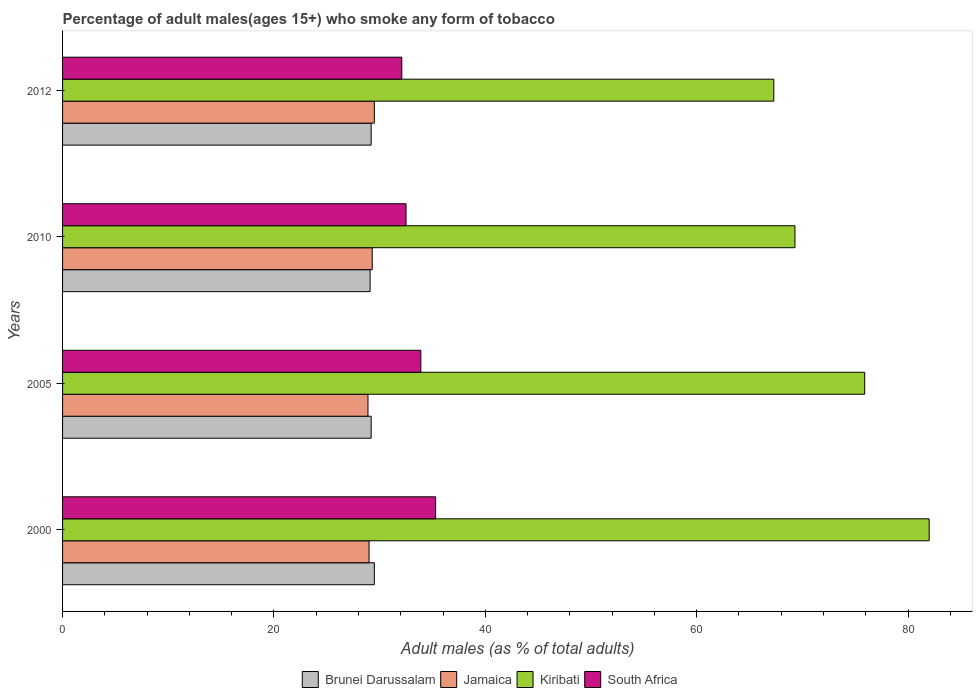How many bars are there on the 3rd tick from the top?
Your answer should be very brief. 4. How many bars are there on the 3rd tick from the bottom?
Make the answer very short. 4. What is the label of the 2nd group of bars from the top?
Keep it short and to the point. 2010. What is the percentage of adult males who smoke in South Africa in 2000?
Offer a terse response. 35.3. Across all years, what is the maximum percentage of adult males who smoke in Jamaica?
Your answer should be compact. 29.5. Across all years, what is the minimum percentage of adult males who smoke in Kiribati?
Provide a short and direct response. 67.3. What is the total percentage of adult males who smoke in Jamaica in the graph?
Ensure brevity in your answer.  116.7. What is the difference between the percentage of adult males who smoke in South Africa in 2005 and that in 2010?
Offer a terse response. 1.4. What is the difference between the percentage of adult males who smoke in Brunei Darussalam in 2010 and the percentage of adult males who smoke in Jamaica in 2012?
Offer a terse response. -0.4. What is the average percentage of adult males who smoke in Brunei Darussalam per year?
Provide a succinct answer. 29.25. In the year 2005, what is the difference between the percentage of adult males who smoke in Jamaica and percentage of adult males who smoke in Brunei Darussalam?
Keep it short and to the point. -0.3. In how many years, is the percentage of adult males who smoke in Kiribati greater than 36 %?
Your answer should be compact. 4. What is the ratio of the percentage of adult males who smoke in Kiribati in 2005 to that in 2010?
Your response must be concise. 1.1. Is the percentage of adult males who smoke in Kiribati in 2005 less than that in 2010?
Offer a terse response. No. What is the difference between the highest and the second highest percentage of adult males who smoke in Kiribati?
Your response must be concise. 6.1. What is the difference between the highest and the lowest percentage of adult males who smoke in Brunei Darussalam?
Give a very brief answer. 0.4. Is the sum of the percentage of adult males who smoke in South Africa in 2005 and 2012 greater than the maximum percentage of adult males who smoke in Kiribati across all years?
Your answer should be very brief. No. Is it the case that in every year, the sum of the percentage of adult males who smoke in South Africa and percentage of adult males who smoke in Kiribati is greater than the sum of percentage of adult males who smoke in Jamaica and percentage of adult males who smoke in Brunei Darussalam?
Provide a succinct answer. Yes. What does the 2nd bar from the top in 2000 represents?
Ensure brevity in your answer.  Kiribati. What does the 2nd bar from the bottom in 2005 represents?
Offer a terse response. Jamaica. How many bars are there?
Keep it short and to the point. 16. Are all the bars in the graph horizontal?
Offer a terse response. Yes. How many years are there in the graph?
Your answer should be very brief. 4. Are the values on the major ticks of X-axis written in scientific E-notation?
Offer a terse response. No. How many legend labels are there?
Your answer should be very brief. 4. How are the legend labels stacked?
Ensure brevity in your answer.  Horizontal. What is the title of the graph?
Offer a terse response. Percentage of adult males(ages 15+) who smoke any form of tobacco. What is the label or title of the X-axis?
Your response must be concise. Adult males (as % of total adults). What is the label or title of the Y-axis?
Ensure brevity in your answer.  Years. What is the Adult males (as % of total adults) of Brunei Darussalam in 2000?
Your answer should be very brief. 29.5. What is the Adult males (as % of total adults) of Jamaica in 2000?
Your answer should be very brief. 29. What is the Adult males (as % of total adults) in Kiribati in 2000?
Give a very brief answer. 82. What is the Adult males (as % of total adults) of South Africa in 2000?
Offer a very short reply. 35.3. What is the Adult males (as % of total adults) in Brunei Darussalam in 2005?
Provide a succinct answer. 29.2. What is the Adult males (as % of total adults) in Jamaica in 2005?
Your answer should be compact. 28.9. What is the Adult males (as % of total adults) of Kiribati in 2005?
Your answer should be very brief. 75.9. What is the Adult males (as % of total adults) of South Africa in 2005?
Provide a succinct answer. 33.9. What is the Adult males (as % of total adults) of Brunei Darussalam in 2010?
Ensure brevity in your answer.  29.1. What is the Adult males (as % of total adults) of Jamaica in 2010?
Offer a very short reply. 29.3. What is the Adult males (as % of total adults) of Kiribati in 2010?
Give a very brief answer. 69.3. What is the Adult males (as % of total adults) of South Africa in 2010?
Ensure brevity in your answer.  32.5. What is the Adult males (as % of total adults) in Brunei Darussalam in 2012?
Provide a short and direct response. 29.2. What is the Adult males (as % of total adults) of Jamaica in 2012?
Make the answer very short. 29.5. What is the Adult males (as % of total adults) in Kiribati in 2012?
Your answer should be compact. 67.3. What is the Adult males (as % of total adults) in South Africa in 2012?
Your answer should be compact. 32.1. Across all years, what is the maximum Adult males (as % of total adults) of Brunei Darussalam?
Give a very brief answer. 29.5. Across all years, what is the maximum Adult males (as % of total adults) in Jamaica?
Your answer should be very brief. 29.5. Across all years, what is the maximum Adult males (as % of total adults) in Kiribati?
Make the answer very short. 82. Across all years, what is the maximum Adult males (as % of total adults) of South Africa?
Your response must be concise. 35.3. Across all years, what is the minimum Adult males (as % of total adults) in Brunei Darussalam?
Give a very brief answer. 29.1. Across all years, what is the minimum Adult males (as % of total adults) in Jamaica?
Your response must be concise. 28.9. Across all years, what is the minimum Adult males (as % of total adults) in Kiribati?
Keep it short and to the point. 67.3. Across all years, what is the minimum Adult males (as % of total adults) in South Africa?
Provide a succinct answer. 32.1. What is the total Adult males (as % of total adults) in Brunei Darussalam in the graph?
Offer a very short reply. 117. What is the total Adult males (as % of total adults) of Jamaica in the graph?
Your answer should be compact. 116.7. What is the total Adult males (as % of total adults) in Kiribati in the graph?
Your answer should be very brief. 294.5. What is the total Adult males (as % of total adults) in South Africa in the graph?
Ensure brevity in your answer.  133.8. What is the difference between the Adult males (as % of total adults) in Brunei Darussalam in 2000 and that in 2005?
Give a very brief answer. 0.3. What is the difference between the Adult males (as % of total adults) of Jamaica in 2000 and that in 2005?
Your response must be concise. 0.1. What is the difference between the Adult males (as % of total adults) in Kiribati in 2000 and that in 2005?
Give a very brief answer. 6.1. What is the difference between the Adult males (as % of total adults) in Brunei Darussalam in 2000 and that in 2010?
Your answer should be compact. 0.4. What is the difference between the Adult males (as % of total adults) of Jamaica in 2000 and that in 2010?
Make the answer very short. -0.3. What is the difference between the Adult males (as % of total adults) in South Africa in 2000 and that in 2010?
Your answer should be compact. 2.8. What is the difference between the Adult males (as % of total adults) of South Africa in 2000 and that in 2012?
Keep it short and to the point. 3.2. What is the difference between the Adult males (as % of total adults) of Kiribati in 2005 and that in 2010?
Make the answer very short. 6.6. What is the difference between the Adult males (as % of total adults) in South Africa in 2005 and that in 2010?
Your answer should be very brief. 1.4. What is the difference between the Adult males (as % of total adults) in Brunei Darussalam in 2005 and that in 2012?
Provide a short and direct response. 0. What is the difference between the Adult males (as % of total adults) in Jamaica in 2005 and that in 2012?
Offer a very short reply. -0.6. What is the difference between the Adult males (as % of total adults) of South Africa in 2005 and that in 2012?
Give a very brief answer. 1.8. What is the difference between the Adult males (as % of total adults) of Brunei Darussalam in 2010 and that in 2012?
Your answer should be very brief. -0.1. What is the difference between the Adult males (as % of total adults) in Jamaica in 2010 and that in 2012?
Give a very brief answer. -0.2. What is the difference between the Adult males (as % of total adults) in Kiribati in 2010 and that in 2012?
Make the answer very short. 2. What is the difference between the Adult males (as % of total adults) of Brunei Darussalam in 2000 and the Adult males (as % of total adults) of Kiribati in 2005?
Your answer should be compact. -46.4. What is the difference between the Adult males (as % of total adults) in Jamaica in 2000 and the Adult males (as % of total adults) in Kiribati in 2005?
Keep it short and to the point. -46.9. What is the difference between the Adult males (as % of total adults) of Jamaica in 2000 and the Adult males (as % of total adults) of South Africa in 2005?
Give a very brief answer. -4.9. What is the difference between the Adult males (as % of total adults) in Kiribati in 2000 and the Adult males (as % of total adults) in South Africa in 2005?
Your response must be concise. 48.1. What is the difference between the Adult males (as % of total adults) of Brunei Darussalam in 2000 and the Adult males (as % of total adults) of Kiribati in 2010?
Offer a terse response. -39.8. What is the difference between the Adult males (as % of total adults) in Jamaica in 2000 and the Adult males (as % of total adults) in Kiribati in 2010?
Your response must be concise. -40.3. What is the difference between the Adult males (as % of total adults) of Jamaica in 2000 and the Adult males (as % of total adults) of South Africa in 2010?
Offer a very short reply. -3.5. What is the difference between the Adult males (as % of total adults) in Kiribati in 2000 and the Adult males (as % of total adults) in South Africa in 2010?
Provide a short and direct response. 49.5. What is the difference between the Adult males (as % of total adults) in Brunei Darussalam in 2000 and the Adult males (as % of total adults) in Kiribati in 2012?
Provide a succinct answer. -37.8. What is the difference between the Adult males (as % of total adults) of Jamaica in 2000 and the Adult males (as % of total adults) of Kiribati in 2012?
Offer a terse response. -38.3. What is the difference between the Adult males (as % of total adults) of Jamaica in 2000 and the Adult males (as % of total adults) of South Africa in 2012?
Offer a very short reply. -3.1. What is the difference between the Adult males (as % of total adults) of Kiribati in 2000 and the Adult males (as % of total adults) of South Africa in 2012?
Make the answer very short. 49.9. What is the difference between the Adult males (as % of total adults) in Brunei Darussalam in 2005 and the Adult males (as % of total adults) in Kiribati in 2010?
Make the answer very short. -40.1. What is the difference between the Adult males (as % of total adults) in Brunei Darussalam in 2005 and the Adult males (as % of total adults) in South Africa in 2010?
Offer a very short reply. -3.3. What is the difference between the Adult males (as % of total adults) of Jamaica in 2005 and the Adult males (as % of total adults) of Kiribati in 2010?
Offer a very short reply. -40.4. What is the difference between the Adult males (as % of total adults) of Jamaica in 2005 and the Adult males (as % of total adults) of South Africa in 2010?
Give a very brief answer. -3.6. What is the difference between the Adult males (as % of total adults) of Kiribati in 2005 and the Adult males (as % of total adults) of South Africa in 2010?
Make the answer very short. 43.4. What is the difference between the Adult males (as % of total adults) of Brunei Darussalam in 2005 and the Adult males (as % of total adults) of Jamaica in 2012?
Keep it short and to the point. -0.3. What is the difference between the Adult males (as % of total adults) in Brunei Darussalam in 2005 and the Adult males (as % of total adults) in Kiribati in 2012?
Provide a succinct answer. -38.1. What is the difference between the Adult males (as % of total adults) in Brunei Darussalam in 2005 and the Adult males (as % of total adults) in South Africa in 2012?
Your answer should be very brief. -2.9. What is the difference between the Adult males (as % of total adults) in Jamaica in 2005 and the Adult males (as % of total adults) in Kiribati in 2012?
Make the answer very short. -38.4. What is the difference between the Adult males (as % of total adults) of Kiribati in 2005 and the Adult males (as % of total adults) of South Africa in 2012?
Ensure brevity in your answer.  43.8. What is the difference between the Adult males (as % of total adults) in Brunei Darussalam in 2010 and the Adult males (as % of total adults) in Kiribati in 2012?
Your response must be concise. -38.2. What is the difference between the Adult males (as % of total adults) in Jamaica in 2010 and the Adult males (as % of total adults) in Kiribati in 2012?
Ensure brevity in your answer.  -38. What is the difference between the Adult males (as % of total adults) of Jamaica in 2010 and the Adult males (as % of total adults) of South Africa in 2012?
Provide a short and direct response. -2.8. What is the difference between the Adult males (as % of total adults) of Kiribati in 2010 and the Adult males (as % of total adults) of South Africa in 2012?
Keep it short and to the point. 37.2. What is the average Adult males (as % of total adults) in Brunei Darussalam per year?
Give a very brief answer. 29.25. What is the average Adult males (as % of total adults) in Jamaica per year?
Keep it short and to the point. 29.18. What is the average Adult males (as % of total adults) in Kiribati per year?
Provide a succinct answer. 73.62. What is the average Adult males (as % of total adults) of South Africa per year?
Keep it short and to the point. 33.45. In the year 2000, what is the difference between the Adult males (as % of total adults) in Brunei Darussalam and Adult males (as % of total adults) in Jamaica?
Your answer should be very brief. 0.5. In the year 2000, what is the difference between the Adult males (as % of total adults) in Brunei Darussalam and Adult males (as % of total adults) in Kiribati?
Keep it short and to the point. -52.5. In the year 2000, what is the difference between the Adult males (as % of total adults) of Jamaica and Adult males (as % of total adults) of Kiribati?
Your response must be concise. -53. In the year 2000, what is the difference between the Adult males (as % of total adults) of Kiribati and Adult males (as % of total adults) of South Africa?
Make the answer very short. 46.7. In the year 2005, what is the difference between the Adult males (as % of total adults) of Brunei Darussalam and Adult males (as % of total adults) of Jamaica?
Your answer should be compact. 0.3. In the year 2005, what is the difference between the Adult males (as % of total adults) in Brunei Darussalam and Adult males (as % of total adults) in Kiribati?
Make the answer very short. -46.7. In the year 2005, what is the difference between the Adult males (as % of total adults) in Brunei Darussalam and Adult males (as % of total adults) in South Africa?
Your answer should be compact. -4.7. In the year 2005, what is the difference between the Adult males (as % of total adults) in Jamaica and Adult males (as % of total adults) in Kiribati?
Provide a short and direct response. -47. In the year 2005, what is the difference between the Adult males (as % of total adults) of Jamaica and Adult males (as % of total adults) of South Africa?
Provide a succinct answer. -5. In the year 2010, what is the difference between the Adult males (as % of total adults) of Brunei Darussalam and Adult males (as % of total adults) of Jamaica?
Provide a short and direct response. -0.2. In the year 2010, what is the difference between the Adult males (as % of total adults) of Brunei Darussalam and Adult males (as % of total adults) of Kiribati?
Offer a very short reply. -40.2. In the year 2010, what is the difference between the Adult males (as % of total adults) in Jamaica and Adult males (as % of total adults) in Kiribati?
Your answer should be compact. -40. In the year 2010, what is the difference between the Adult males (as % of total adults) in Jamaica and Adult males (as % of total adults) in South Africa?
Your answer should be compact. -3.2. In the year 2010, what is the difference between the Adult males (as % of total adults) in Kiribati and Adult males (as % of total adults) in South Africa?
Your answer should be very brief. 36.8. In the year 2012, what is the difference between the Adult males (as % of total adults) of Brunei Darussalam and Adult males (as % of total adults) of Jamaica?
Make the answer very short. -0.3. In the year 2012, what is the difference between the Adult males (as % of total adults) in Brunei Darussalam and Adult males (as % of total adults) in Kiribati?
Offer a terse response. -38.1. In the year 2012, what is the difference between the Adult males (as % of total adults) in Jamaica and Adult males (as % of total adults) in Kiribati?
Offer a very short reply. -37.8. In the year 2012, what is the difference between the Adult males (as % of total adults) of Kiribati and Adult males (as % of total adults) of South Africa?
Offer a terse response. 35.2. What is the ratio of the Adult males (as % of total adults) in Brunei Darussalam in 2000 to that in 2005?
Your answer should be compact. 1.01. What is the ratio of the Adult males (as % of total adults) in Jamaica in 2000 to that in 2005?
Offer a very short reply. 1. What is the ratio of the Adult males (as % of total adults) of Kiribati in 2000 to that in 2005?
Ensure brevity in your answer.  1.08. What is the ratio of the Adult males (as % of total adults) of South Africa in 2000 to that in 2005?
Offer a terse response. 1.04. What is the ratio of the Adult males (as % of total adults) of Brunei Darussalam in 2000 to that in 2010?
Your response must be concise. 1.01. What is the ratio of the Adult males (as % of total adults) in Kiribati in 2000 to that in 2010?
Your answer should be compact. 1.18. What is the ratio of the Adult males (as % of total adults) of South Africa in 2000 to that in 2010?
Offer a very short reply. 1.09. What is the ratio of the Adult males (as % of total adults) in Brunei Darussalam in 2000 to that in 2012?
Offer a very short reply. 1.01. What is the ratio of the Adult males (as % of total adults) in Jamaica in 2000 to that in 2012?
Provide a short and direct response. 0.98. What is the ratio of the Adult males (as % of total adults) in Kiribati in 2000 to that in 2012?
Offer a very short reply. 1.22. What is the ratio of the Adult males (as % of total adults) of South Africa in 2000 to that in 2012?
Make the answer very short. 1.1. What is the ratio of the Adult males (as % of total adults) in Brunei Darussalam in 2005 to that in 2010?
Provide a succinct answer. 1. What is the ratio of the Adult males (as % of total adults) in Jamaica in 2005 to that in 2010?
Offer a terse response. 0.99. What is the ratio of the Adult males (as % of total adults) of Kiribati in 2005 to that in 2010?
Ensure brevity in your answer.  1.1. What is the ratio of the Adult males (as % of total adults) in South Africa in 2005 to that in 2010?
Provide a short and direct response. 1.04. What is the ratio of the Adult males (as % of total adults) of Jamaica in 2005 to that in 2012?
Your answer should be very brief. 0.98. What is the ratio of the Adult males (as % of total adults) of Kiribati in 2005 to that in 2012?
Your answer should be compact. 1.13. What is the ratio of the Adult males (as % of total adults) of South Africa in 2005 to that in 2012?
Your answer should be very brief. 1.06. What is the ratio of the Adult males (as % of total adults) of Jamaica in 2010 to that in 2012?
Keep it short and to the point. 0.99. What is the ratio of the Adult males (as % of total adults) of Kiribati in 2010 to that in 2012?
Your answer should be very brief. 1.03. What is the ratio of the Adult males (as % of total adults) in South Africa in 2010 to that in 2012?
Make the answer very short. 1.01. What is the difference between the highest and the second highest Adult males (as % of total adults) in Brunei Darussalam?
Your answer should be very brief. 0.3. What is the difference between the highest and the second highest Adult males (as % of total adults) of South Africa?
Offer a terse response. 1.4. What is the difference between the highest and the lowest Adult males (as % of total adults) of Brunei Darussalam?
Provide a short and direct response. 0.4. What is the difference between the highest and the lowest Adult males (as % of total adults) of Jamaica?
Provide a short and direct response. 0.6. What is the difference between the highest and the lowest Adult males (as % of total adults) of South Africa?
Your answer should be very brief. 3.2. 